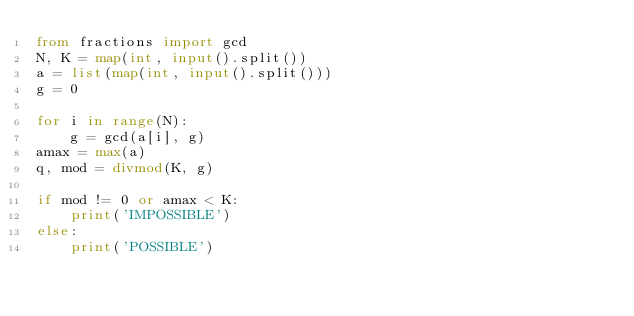Convert code to text. <code><loc_0><loc_0><loc_500><loc_500><_Python_>from fractions import gcd
N, K = map(int, input().split())
a = list(map(int, input().split()))
g = 0

for i in range(N):
    g = gcd(a[i], g)
amax = max(a)
q, mod = divmod(K, g)

if mod != 0 or amax < K:
    print('IMPOSSIBLE')
else:
    print('POSSIBLE')</code> 